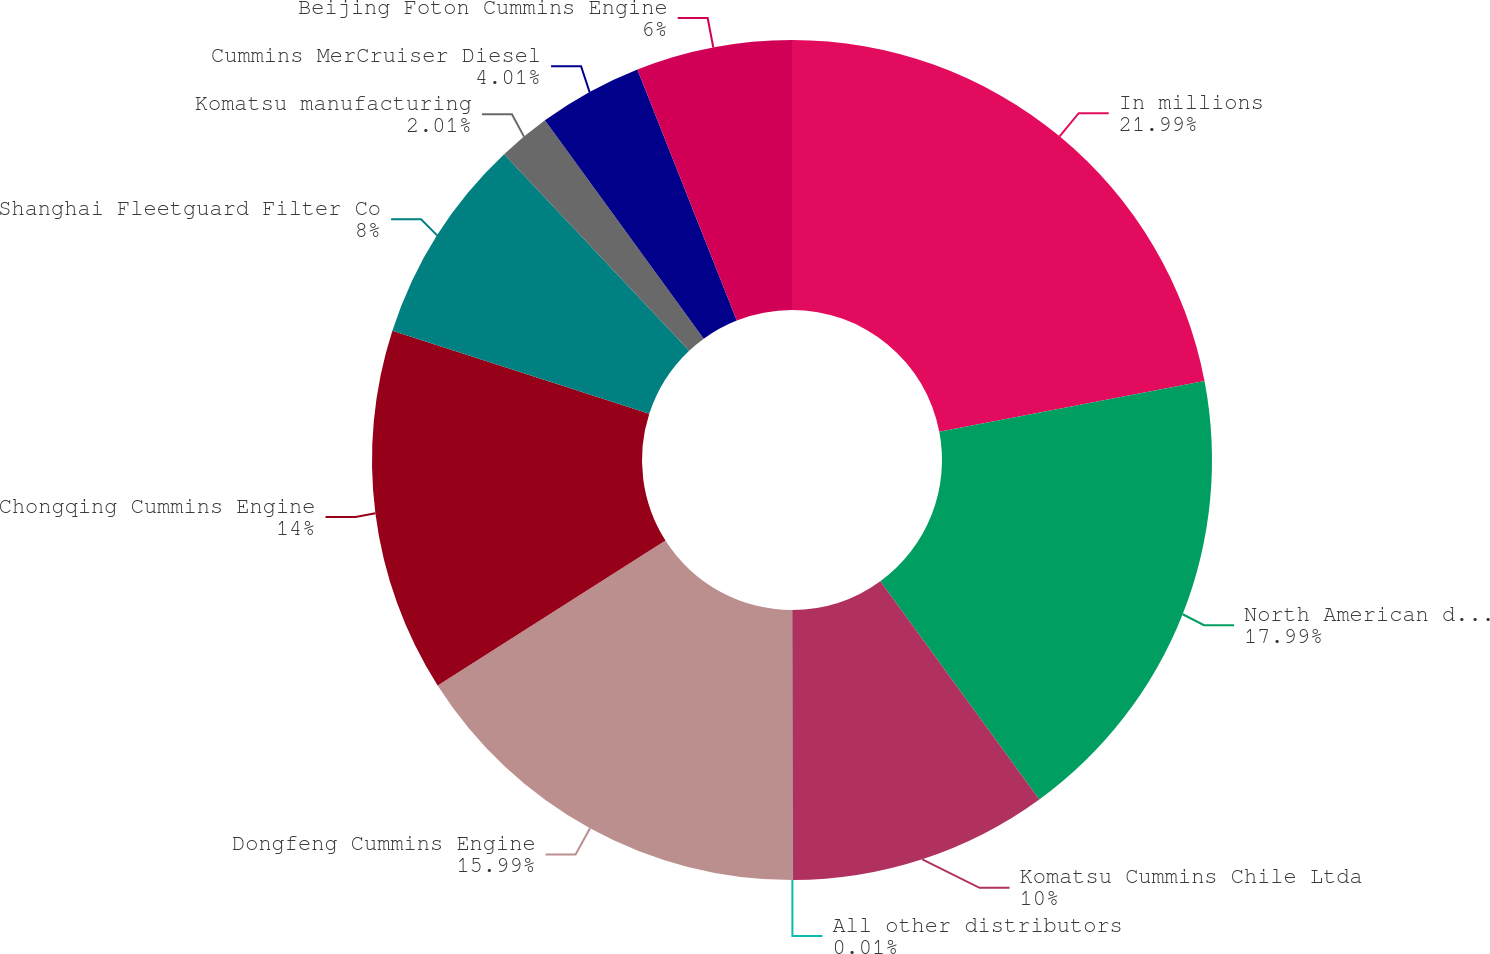Convert chart to OTSL. <chart><loc_0><loc_0><loc_500><loc_500><pie_chart><fcel>In millions<fcel>North American distributors<fcel>Komatsu Cummins Chile Ltda<fcel>All other distributors<fcel>Dongfeng Cummins Engine<fcel>Chongqing Cummins Engine<fcel>Shanghai Fleetguard Filter Co<fcel>Komatsu manufacturing<fcel>Cummins MerCruiser Diesel<fcel>Beijing Foton Cummins Engine<nl><fcel>21.99%<fcel>17.99%<fcel>10.0%<fcel>0.01%<fcel>15.99%<fcel>14.0%<fcel>8.0%<fcel>2.01%<fcel>4.01%<fcel>6.0%<nl></chart> 